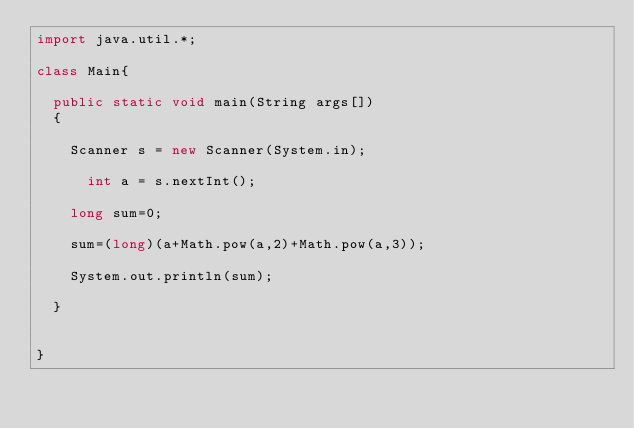Convert code to text. <code><loc_0><loc_0><loc_500><loc_500><_Java_>import java.util.*;
 
class Main{
  
  public static void main(String args[])
  {
    
    Scanner s = new Scanner(System.in);
      
      int a = s.nextInt();
    	
    long sum=0;
    
    sum=(long)(a+Math.pow(a,2)+Math.pow(a,3));
    
    System.out.println(sum);
    
  }
  
  
}</code> 